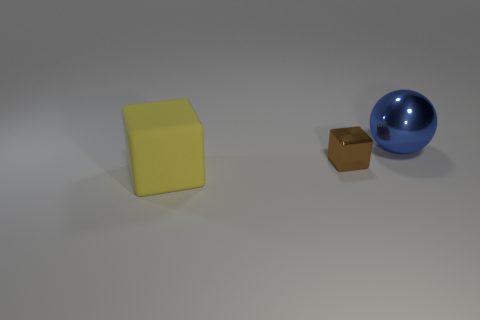Is the material of the big thing that is in front of the blue ball the same as the object that is behind the shiny block?
Offer a terse response. No. What number of things are behind the big yellow cube and on the left side of the shiny ball?
Your answer should be compact. 1. Is there a small yellow thing of the same shape as the blue shiny object?
Offer a very short reply. No. There is another matte object that is the same size as the blue thing; what is its shape?
Offer a terse response. Cube. Are there the same number of blue balls right of the blue metal thing and brown metallic cubes that are behind the small metallic thing?
Offer a very short reply. Yes. There is a shiny object in front of the large thing that is on the right side of the big yellow object; what is its size?
Your answer should be very brief. Small. Are there any yellow cubes of the same size as the rubber object?
Give a very brief answer. No. There is a block that is the same material as the big blue sphere; what is its color?
Keep it short and to the point. Brown. Are there fewer rubber blocks than rubber balls?
Offer a very short reply. No. What is the material of the thing that is to the left of the large metal object and behind the matte cube?
Provide a short and direct response. Metal. 